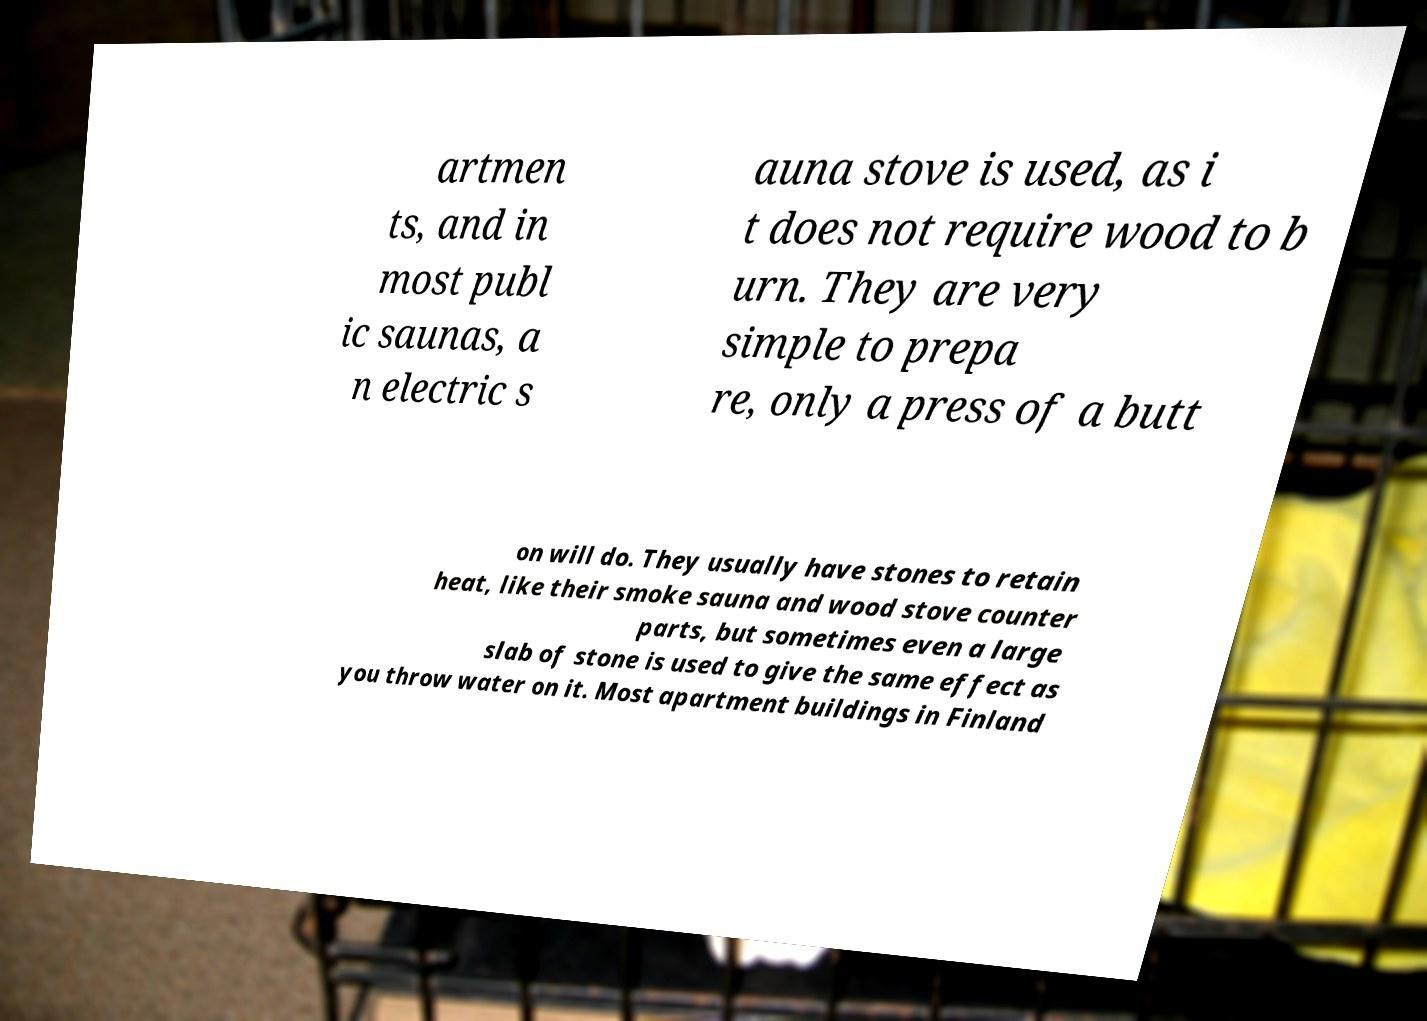What messages or text are displayed in this image? I need them in a readable, typed format. artmen ts, and in most publ ic saunas, a n electric s auna stove is used, as i t does not require wood to b urn. They are very simple to prepa re, only a press of a butt on will do. They usually have stones to retain heat, like their smoke sauna and wood stove counter parts, but sometimes even a large slab of stone is used to give the same effect as you throw water on it. Most apartment buildings in Finland 